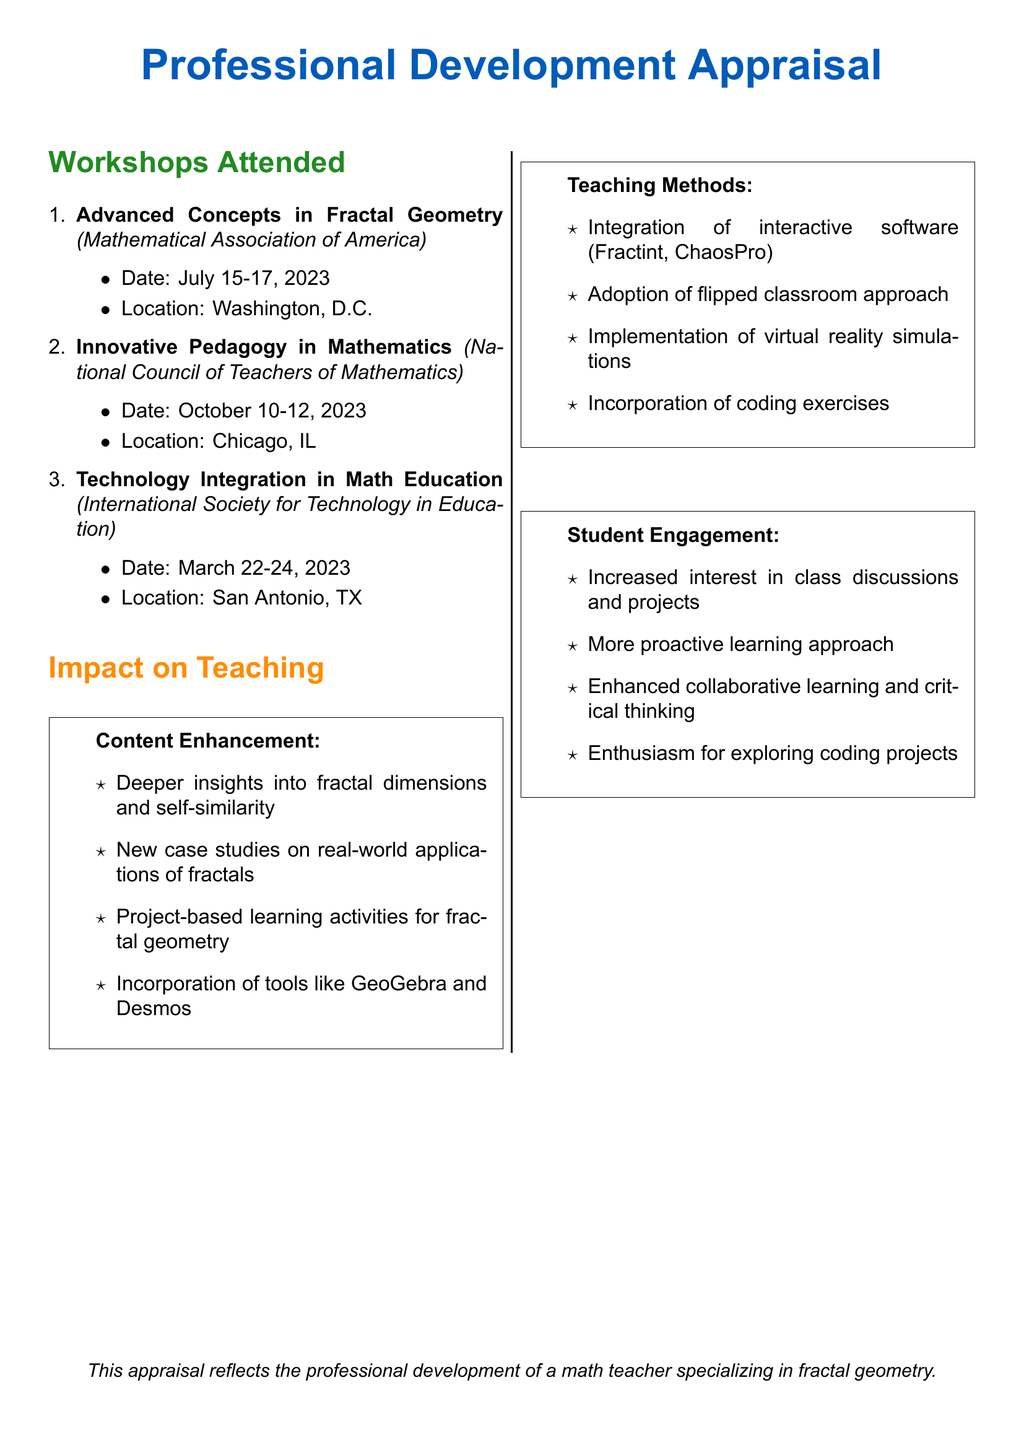What is the first workshop attended? The first workshop listed in the document is "Advanced Concepts in Fractal Geometry."
Answer: Advanced Concepts in Fractal Geometry When did the Innovative Pedagogy in Mathematics workshop take place? The date for the Innovative Pedagogy in Mathematics workshop is October 10-12, 2023.
Answer: October 10-12, 2023 Where was the Technology Integration in Math Education workshop held? The location of the Technology Integration in Math Education workshop is San Antonio, TX.
Answer: San Antonio, TX What software is mentioned for interactive integration in teaching? The document mentions "Fractint" and "ChaosPro" as interactive software.
Answer: Fractint, ChaosPro What impact is noted for enhancing student engagement? The document states that there was "increased interest in class discussions and projects."
Answer: Increased interest in class discussions and projects How many professional development workshops are listed? The document lists a total of three professional development workshops attended.
Answer: Three What pedagogical approach was adopted in teaching methods? The adopted pedagogical approach mentioned is "flipped classroom approach."
Answer: Flipped classroom approach Which tools are suggested for incorporation with fractal geometry content? The tools suggested for incorporation are GeoGebra and Desmos.
Answer: GeoGebra and Desmos What is the main focus of this appraisal document? The main focus of the document is the professional development of a math teacher specializing in fractal geometry.
Answer: Professional development of a math teacher specializing in fractal geometry 